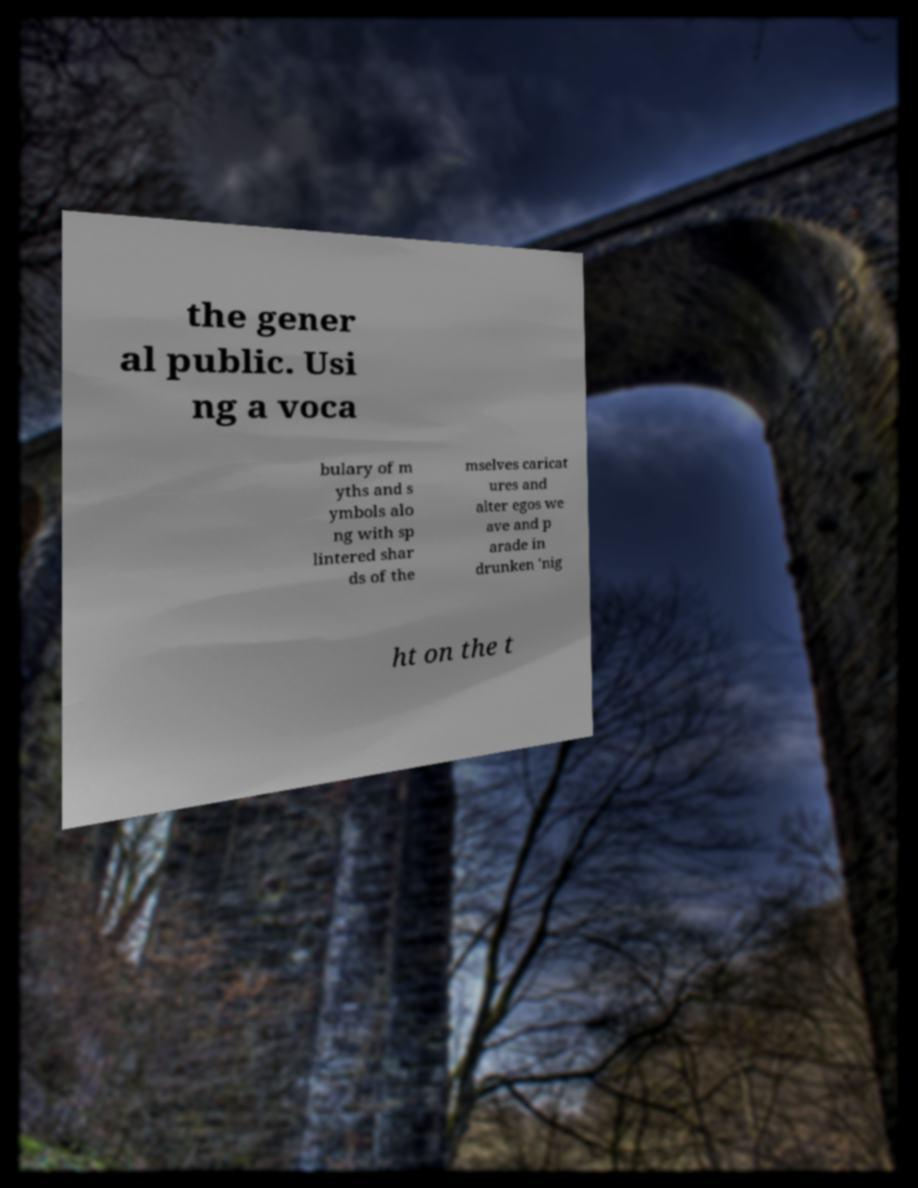Can you read and provide the text displayed in the image?This photo seems to have some interesting text. Can you extract and type it out for me? the gener al public. Usi ng a voca bulary of m yths and s ymbols alo ng with sp lintered shar ds of the mselves caricat ures and alter egos we ave and p arade in drunken 'nig ht on the t 